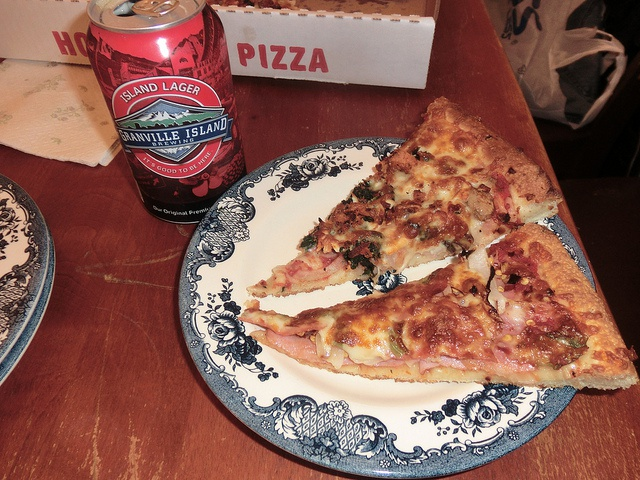Describe the objects in this image and their specific colors. I can see dining table in salmon, maroon, and brown tones, pizza in salmon, tan, and brown tones, and pizza in salmon, brown, tan, and maroon tones in this image. 